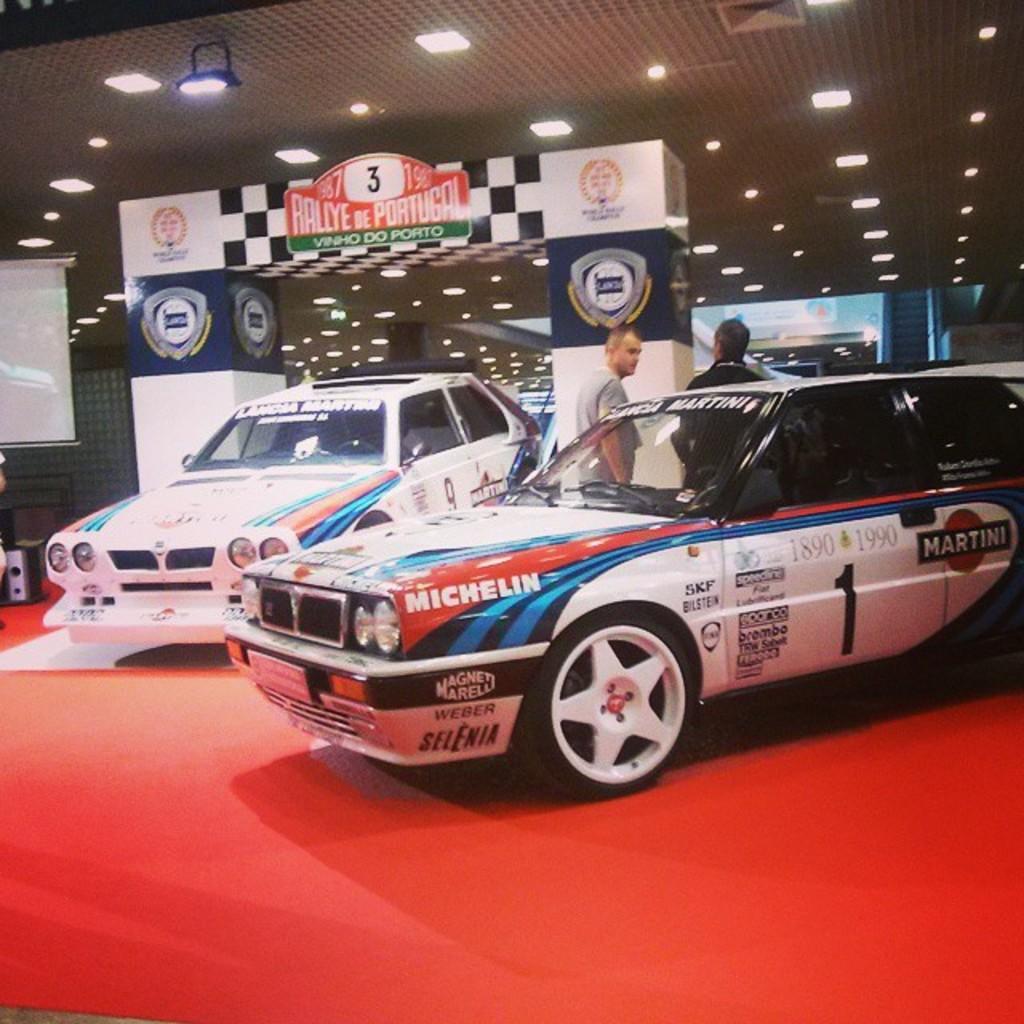Can you describe this image briefly? In this picture there is a woman who is standing near to the cars. Beside them I can see the banner. At the top I can see many lights on the roof of the building. On the left there is a projector screen. At the bottom I can see the red carpet. 